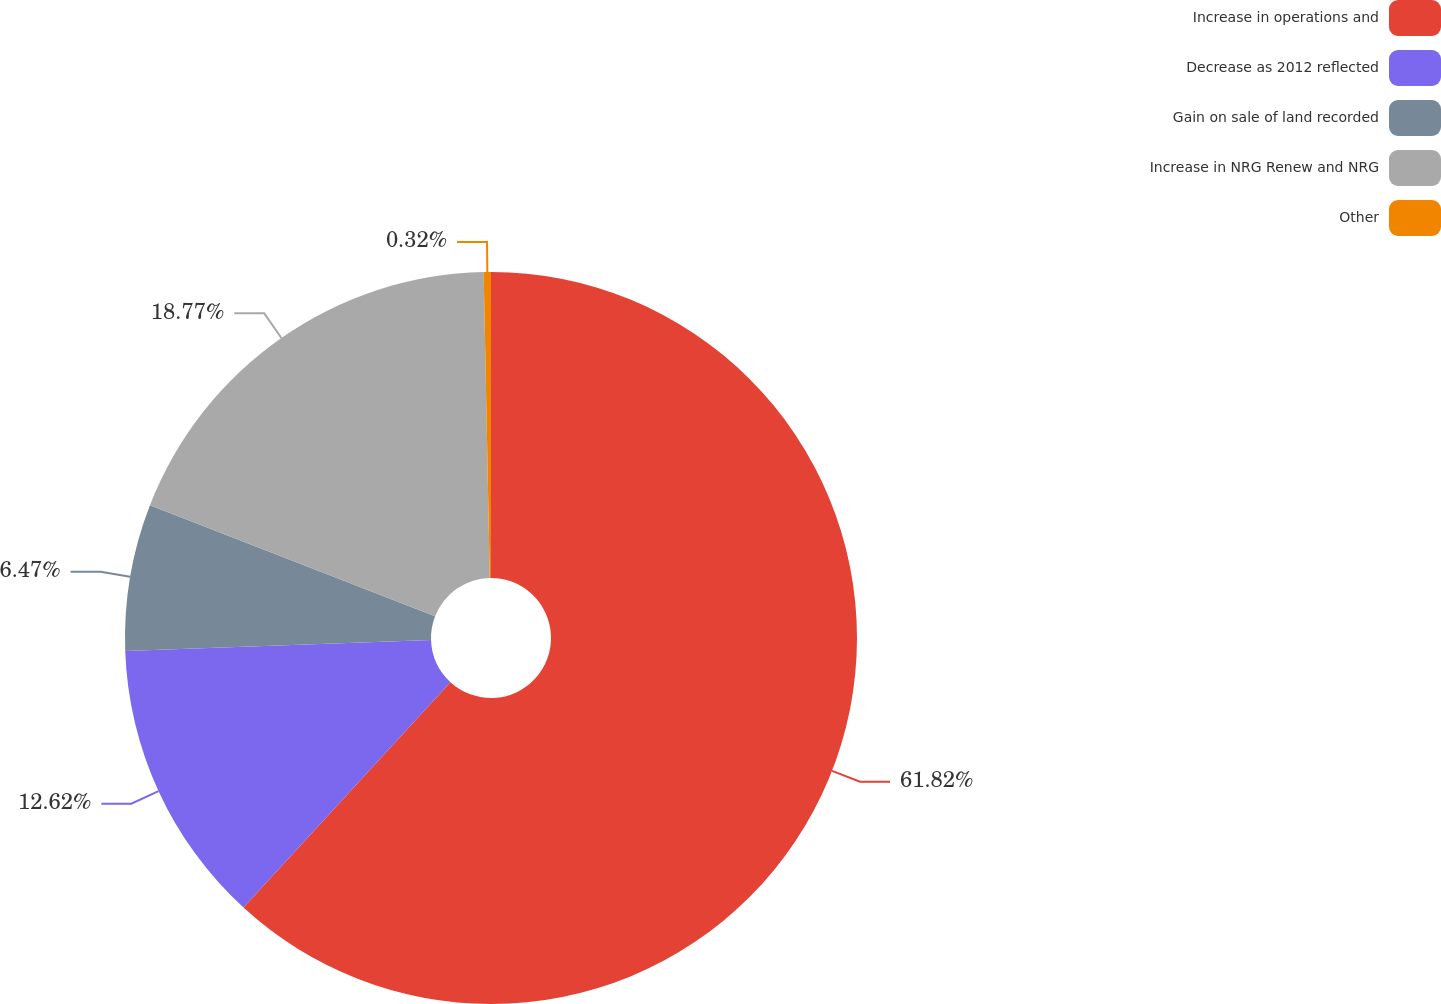Convert chart. <chart><loc_0><loc_0><loc_500><loc_500><pie_chart><fcel>Increase in operations and<fcel>Decrease as 2012 reflected<fcel>Gain on sale of land recorded<fcel>Increase in NRG Renew and NRG<fcel>Other<nl><fcel>61.82%<fcel>12.62%<fcel>6.47%<fcel>18.77%<fcel>0.32%<nl></chart> 